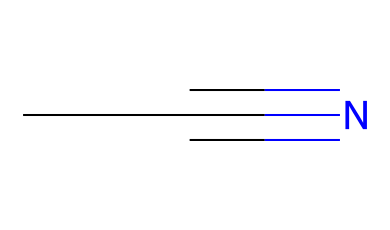What is the molecular formula of acetonitrile? The SMILES representation "CC#N" indicates there are two carbon atoms (C), three hydrogen atoms (H), and one nitrogen atom (N) in the structure. Therefore, combining these gives the molecular formula C2H3N.
Answer: C2H3N How many hydrogen atoms are present in acetonitrile? From the molecular formula derived from the SMILES, C2H3N, it clearly shows that there are three hydrogen atoms in acetonitrile.
Answer: 3 What is the functional group present in acetonitrile? In the chemical structure represented by "CC#N", the presence of the nitrile group, characterized by a carbon triple-bonded to a nitrogen (the "#N" indicates a triple bond), identifies the functional group as a nitrile.
Answer: nitrile How many carbon atoms are in acetonitrile? Looking at the SMILES notation "CC#N", there are two 'C' characters, indicating that there are two carbon atoms in the acetonitrile structure.
Answer: 2 What type of solvent is acetonitrile commonly used as? Acetonitrile is widely recognized as a polar aprotic solvent, which is mainly utilized in organic and pharmaceutical synthesis. Its solvent properties are derived from its molecular structure.
Answer: polar aprotic What is the characteristic bond type found in acetonitrile? The "C#N" portion of the SMILES indicates a triple bond between the last carbon and nitrogen atom, which is characteristic of nitriles. This bond type significantly influences its chemical properties.
Answer: triple bond 